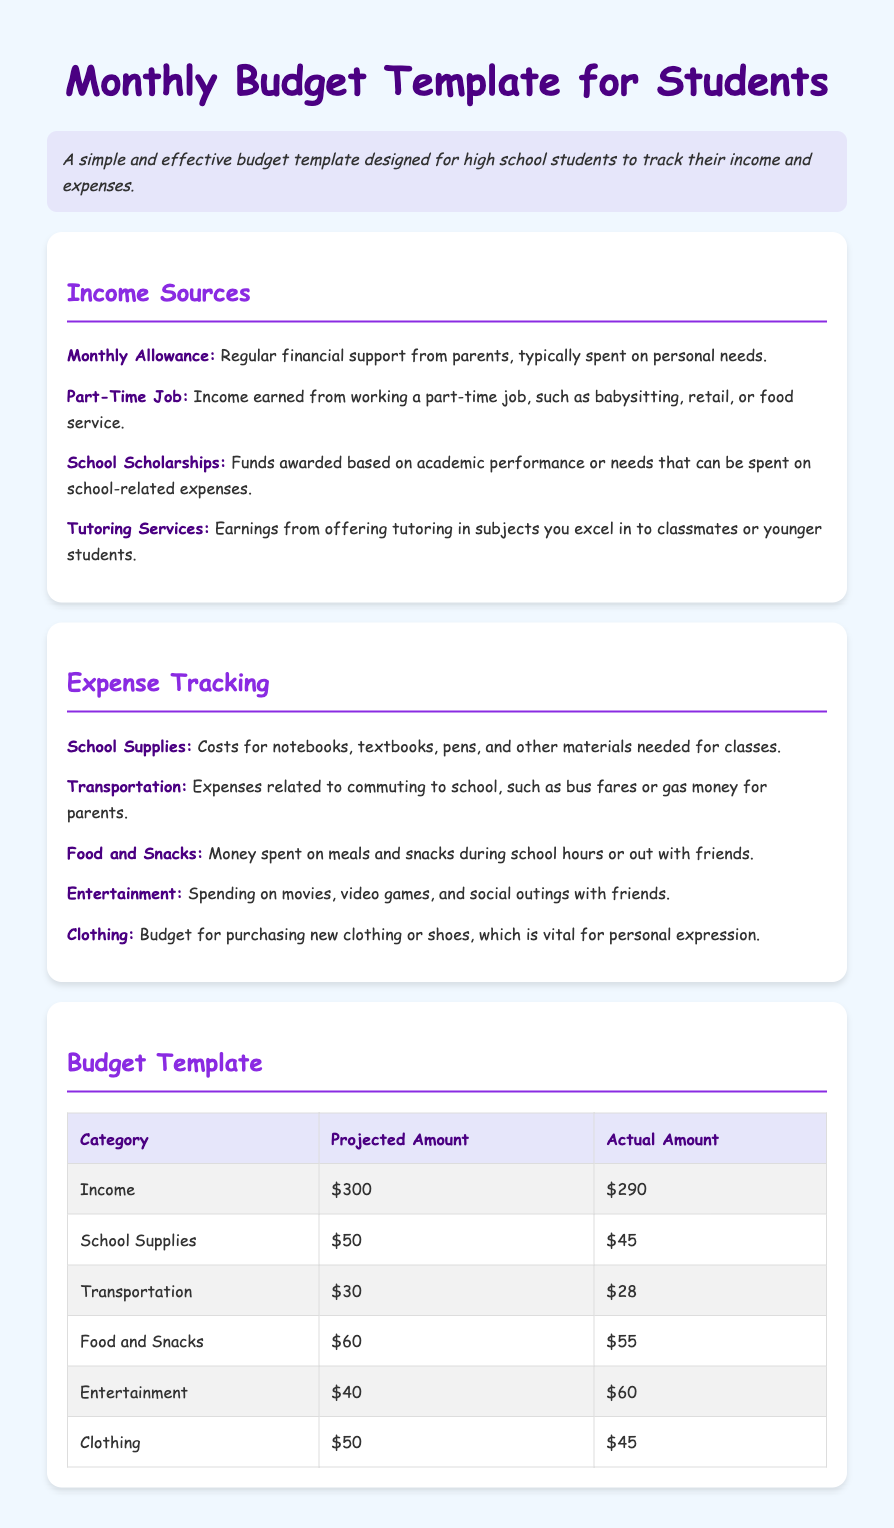what is the monthly allowance? The monthly allowance is defined as regular financial support from parents.
Answer: Monthly Allowance what is one example of income from a part-time job? A part-time job can include working in areas such as babysitting, retail, or food service.
Answer: Babysitting what is the projected amount for food and snacks? The projected amount is the budgeted figure set for that category of expense.
Answer: $60 how much was actually spent on transportation? This refers to the actual amount recorded after tracking expenses.
Answer: $28 which expense category has the highest actual amount? This question focuses on identifying the highest expenditure among the listed categories.
Answer: Entertainment how many sources of income are listed in the document? The document explicitly lists several income sources that students can have.
Answer: Four what is an example of an expense related to school supplies? The document lists specific items under the school supplies category to illustrate the expenses.
Answer: Notebooks what color is the background of the document? The background color helps to determine the overall aesthetics of the document and its readability.
Answer: Light blue what does the budget template include? The budget template consists of projected and actual amounts for various expenditure and income categories.
Answer: Income and expenses 